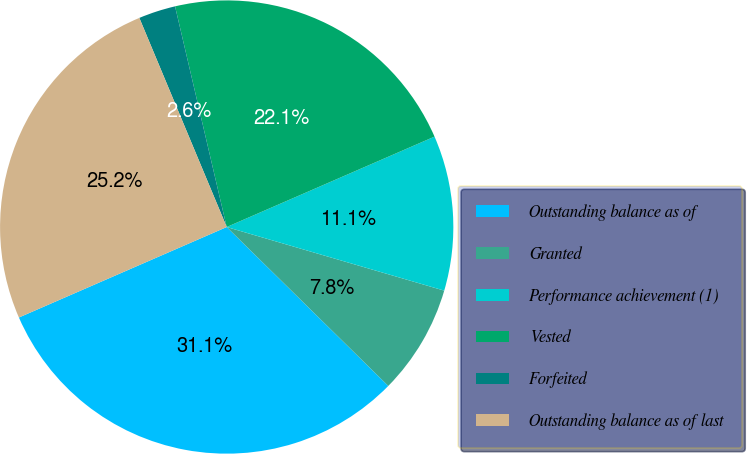Convert chart. <chart><loc_0><loc_0><loc_500><loc_500><pie_chart><fcel>Outstanding balance as of<fcel>Granted<fcel>Performance achievement (1)<fcel>Vested<fcel>Forfeited<fcel>Outstanding balance as of last<nl><fcel>31.1%<fcel>7.84%<fcel>11.06%<fcel>22.13%<fcel>2.64%<fcel>25.24%<nl></chart> 